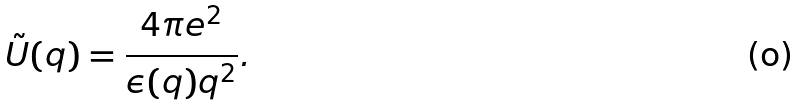Convert formula to latex. <formula><loc_0><loc_0><loc_500><loc_500>\tilde { U } ( { q } ) = \frac { 4 \pi e ^ { 2 } } { \epsilon ( { q } ) q ^ { 2 } } .</formula> 